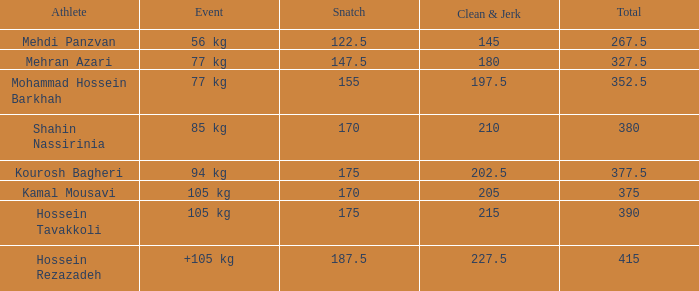What is the total that had an event of +105 kg and clean & jerk less than 227.5? 0.0. Parse the table in full. {'header': ['Athlete', 'Event', 'Snatch', 'Clean & Jerk', 'Total'], 'rows': [['Mehdi Panzvan', '56 kg', '122.5', '145', '267.5'], ['Mehran Azari', '77 kg', '147.5', '180', '327.5'], ['Mohammad Hossein Barkhah', '77 kg', '155', '197.5', '352.5'], ['Shahin Nassirinia', '85 kg', '170', '210', '380'], ['Kourosh Bagheri', '94 kg', '175', '202.5', '377.5'], ['Kamal Mousavi', '105 kg', '170', '205', '375'], ['Hossein Tavakkoli', '105 kg', '175', '215', '390'], ['Hossein Rezazadeh', '+105 kg', '187.5', '227.5', '415']]} 